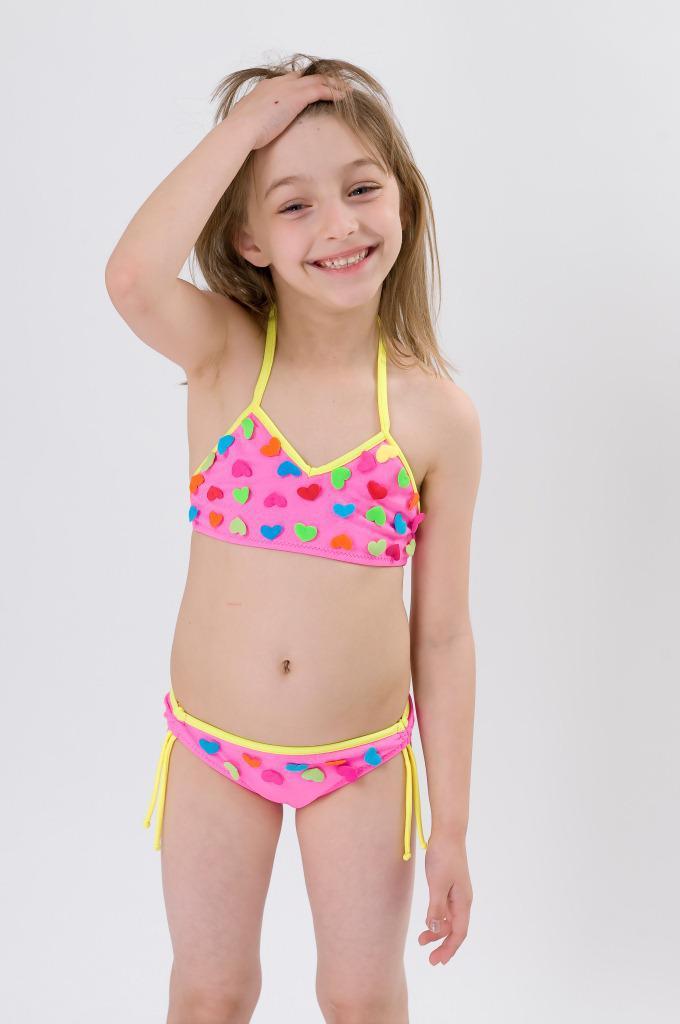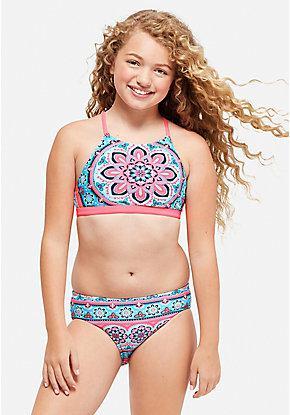The first image is the image on the left, the second image is the image on the right. Given the left and right images, does the statement "At least one person is wearing a bracelet." hold true? Answer yes or no. No. The first image is the image on the left, the second image is the image on the right. Considering the images on both sides, is "The model in one of the images does not have her right arm hanging by her side." valid? Answer yes or no. Yes. 